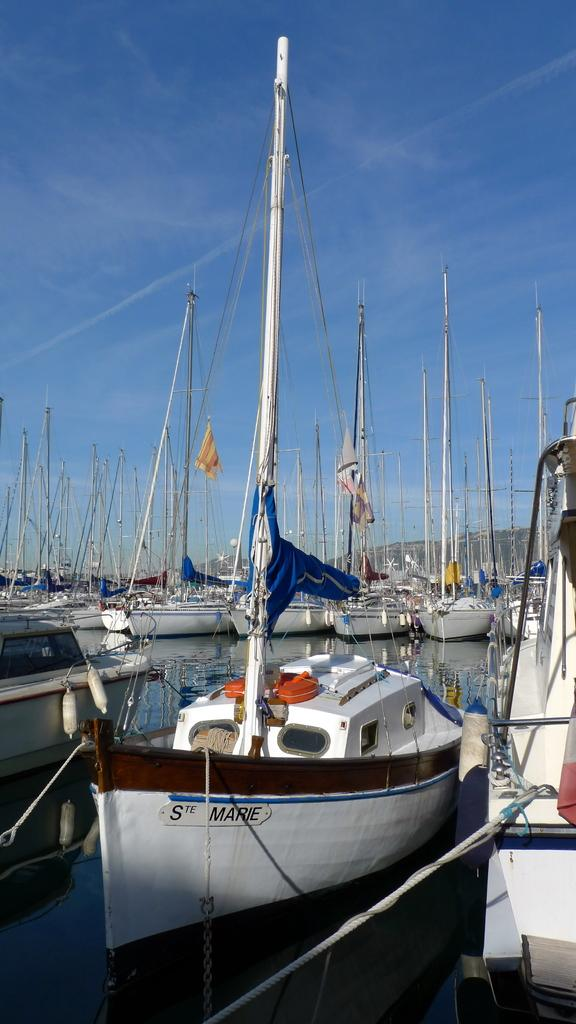What type of vehicles are in the image? There are boats in the image. Where are the boats located? The boats are on the water. What can be seen in the distance in the image? There are mountains visible in the background of the image. What color is the sky in the background of the image? The sky is blue in the background of the image. What type of spade is being used to dig near the boats in the image? There is no spade present in the image; it features boats on the water with mountains and a blue sky in the background. 